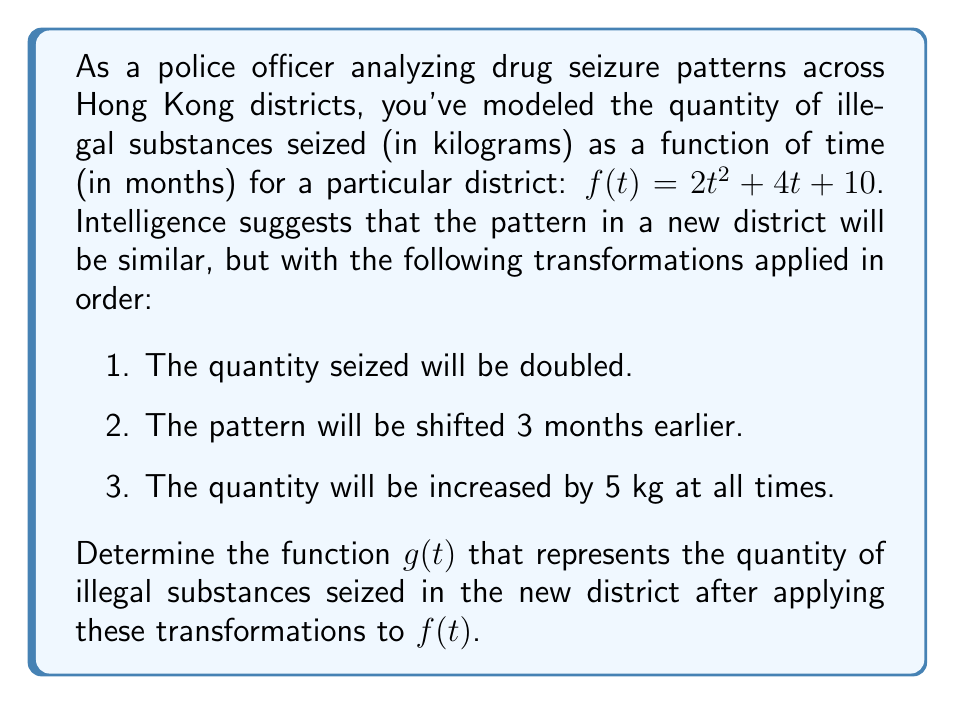Teach me how to tackle this problem. Let's apply the transformations step by step:

1. Doubling the quantity seized:
   This is a vertical stretch by a factor of 2.
   $h_1(t) = 2f(t) = 2(2t^2 + 4t + 10) = 4t^2 + 8t + 20$

2. Shifting the pattern 3 months earlier:
   This is a horizontal shift 3 units to the right. We replace $t$ with $(t+3)$.
   $h_2(t) = h_1(t+3) = 4(t+3)^2 + 8(t+3) + 20$
   $h_2(t) = 4(t^2 + 6t + 9) + 8t + 24 + 20$
   $h_2(t) = 4t^2 + 24t + 36 + 8t + 44$
   $h_2(t) = 4t^2 + 32t + 80$

3. Increasing the quantity by 5 kg at all times:
   This is a vertical shift 5 units up.
   $g(t) = h_2(t) + 5 = (4t^2 + 32t + 80) + 5$
   $g(t) = 4t^2 + 32t + 85$

Therefore, the final transformed function $g(t)$ represents the quantity of illegal substances seized in the new district after applying all the given transformations to $f(t)$.
Answer: $g(t) = 4t^2 + 32t + 85$ 